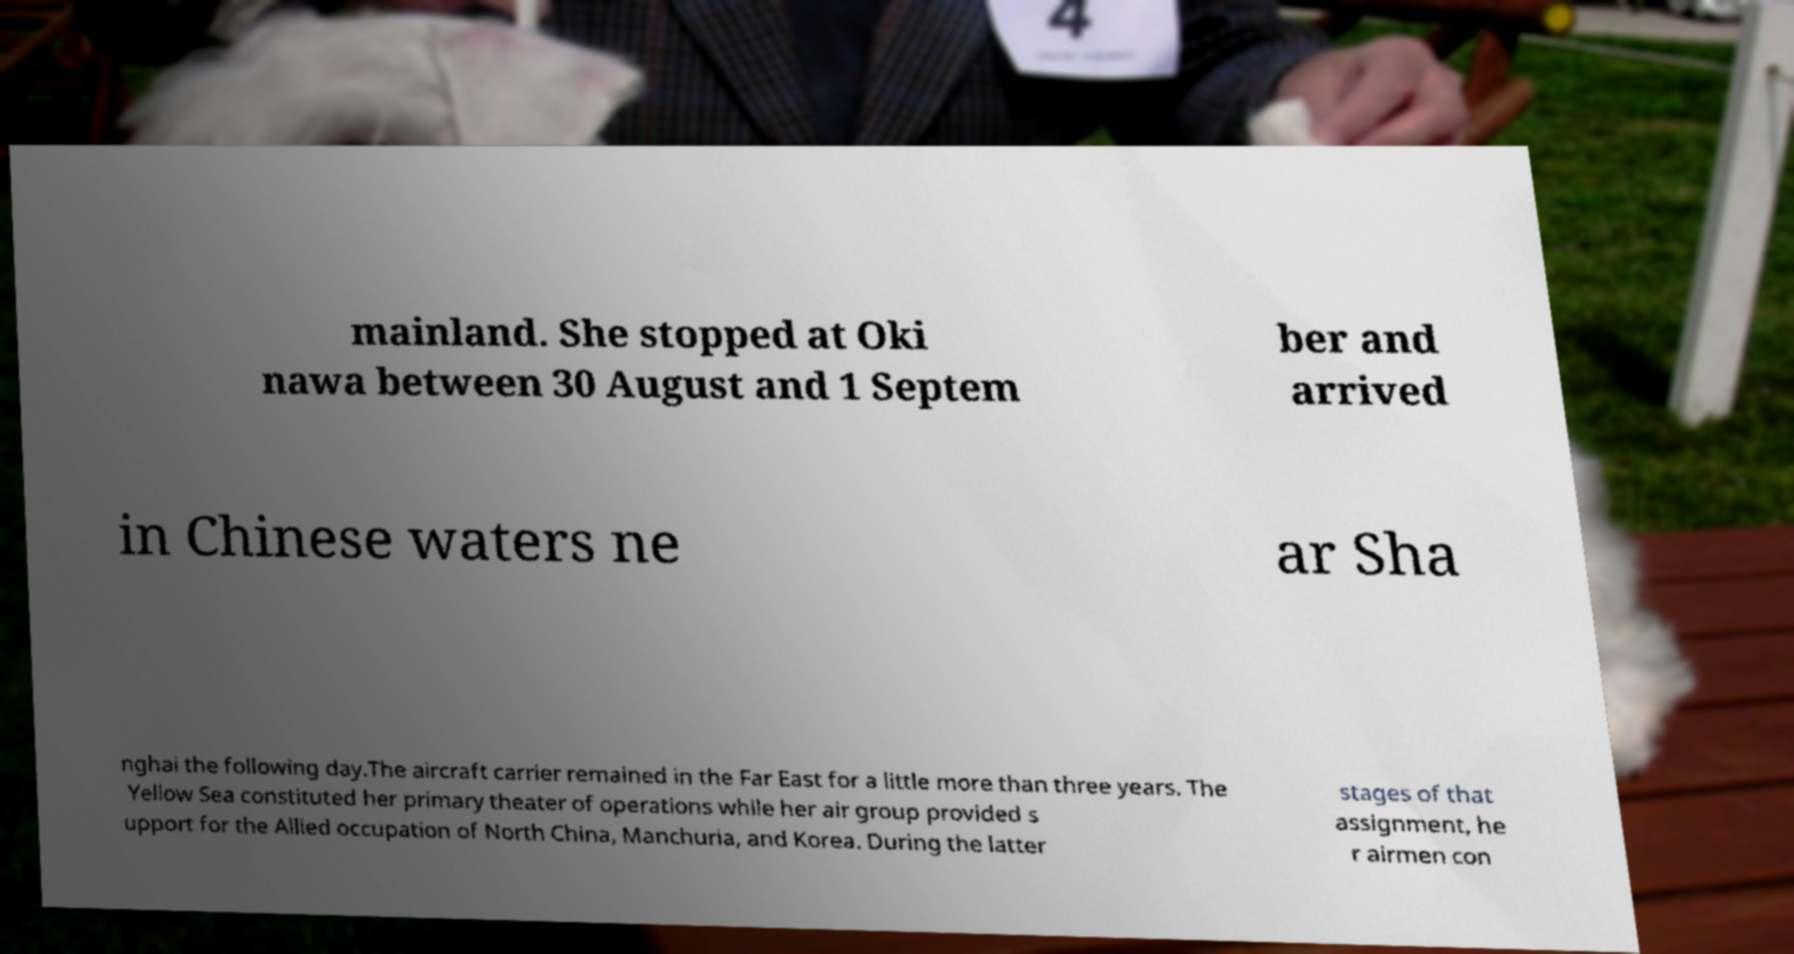What messages or text are displayed in this image? I need them in a readable, typed format. mainland. She stopped at Oki nawa between 30 August and 1 Septem ber and arrived in Chinese waters ne ar Sha nghai the following day.The aircraft carrier remained in the Far East for a little more than three years. The Yellow Sea constituted her primary theater of operations while her air group provided s upport for the Allied occupation of North China, Manchuria, and Korea. During the latter stages of that assignment, he r airmen con 